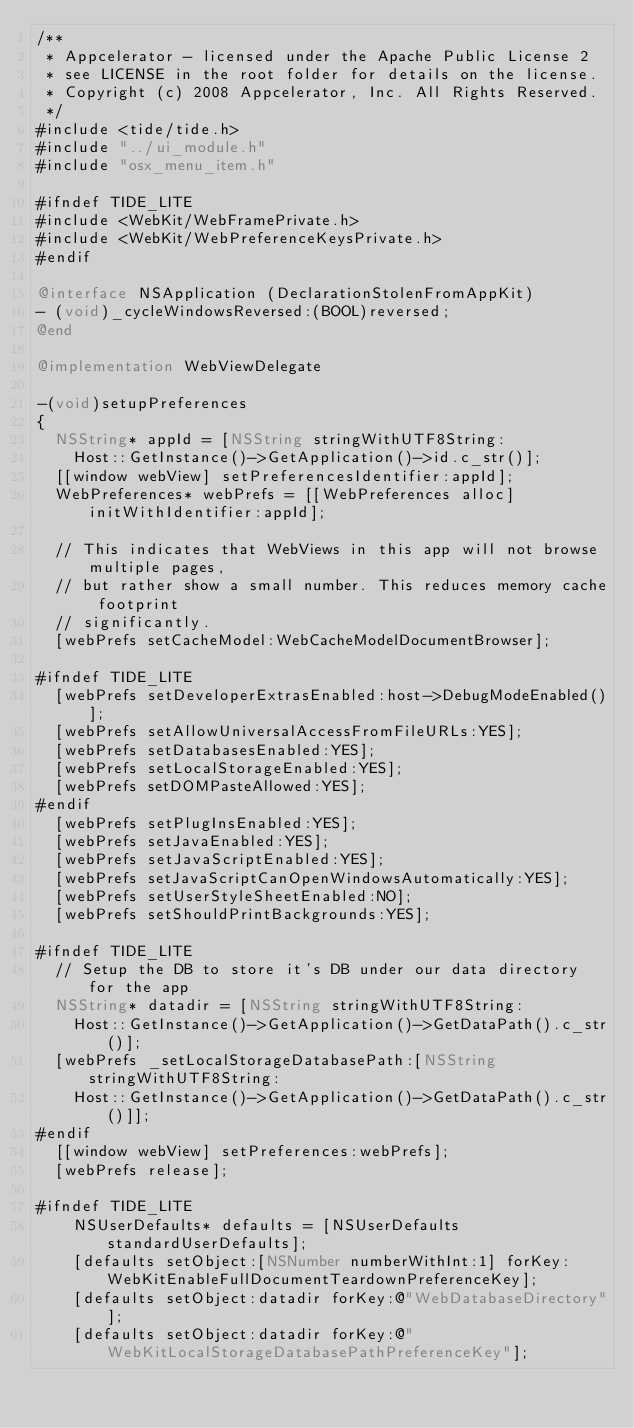Convert code to text. <code><loc_0><loc_0><loc_500><loc_500><_ObjectiveC_>/**
 * Appcelerator - licensed under the Apache Public License 2
 * see LICENSE in the root folder for details on the license.
 * Copyright (c) 2008 Appcelerator, Inc. All Rights Reserved.
 */
#include <tide/tide.h>
#include "../ui_module.h"
#include "osx_menu_item.h"

#ifndef TIDE_LITE
#include <WebKit/WebFramePrivate.h>
#include <WebKit/WebPreferenceKeysPrivate.h>
#endif

@interface NSApplication (DeclarationStolenFromAppKit)
- (void)_cycleWindowsReversed:(BOOL)reversed;
@end

@implementation WebViewDelegate

-(void)setupPreferences
{
	NSString* appId = [NSString stringWithUTF8String:
		Host::GetInstance()->GetApplication()->id.c_str()];
	[[window webView] setPreferencesIdentifier:appId];
	WebPreferences* webPrefs = [[WebPreferences alloc] initWithIdentifier:appId];

	// This indicates that WebViews in this app will not browse multiple pages,
	// but rather show a small number. This reduces memory cache footprint
	// significantly.
	[webPrefs setCacheModel:WebCacheModelDocumentBrowser];

#ifndef TIDE_LITE
	[webPrefs setDeveloperExtrasEnabled:host->DebugModeEnabled()];
	[webPrefs setAllowUniversalAccessFromFileURLs:YES];
	[webPrefs setDatabasesEnabled:YES];
	[webPrefs setLocalStorageEnabled:YES];
	[webPrefs setDOMPasteAllowed:YES];
#endif
	[webPrefs setPlugInsEnabled:YES];
	[webPrefs setJavaEnabled:YES];
	[webPrefs setJavaScriptEnabled:YES];
	[webPrefs setJavaScriptCanOpenWindowsAutomatically:YES];
	[webPrefs setUserStyleSheetEnabled:NO];
	[webPrefs setShouldPrintBackgrounds:YES];

#ifndef TIDE_LITE
	// Setup the DB to store it's DB under our data directory for the app
	NSString* datadir = [NSString stringWithUTF8String:
		Host::GetInstance()->GetApplication()->GetDataPath().c_str()];
	[webPrefs _setLocalStorageDatabasePath:[NSString stringWithUTF8String:
		Host::GetInstance()->GetApplication()->GetDataPath().c_str()]];
#endif		
	[[window webView] setPreferences:webPrefs];
	[webPrefs release];

#ifndef TIDE_LITE
		NSUserDefaults* defaults = [NSUserDefaults standardUserDefaults];
		[defaults setObject:[NSNumber numberWithInt:1] forKey:WebKitEnableFullDocumentTeardownPreferenceKey];
		[defaults setObject:datadir forKey:@"WebDatabaseDirectory"];
		[defaults setObject:datadir forKey:@"WebKitLocalStorageDatabasePathPreferenceKey"];</code> 